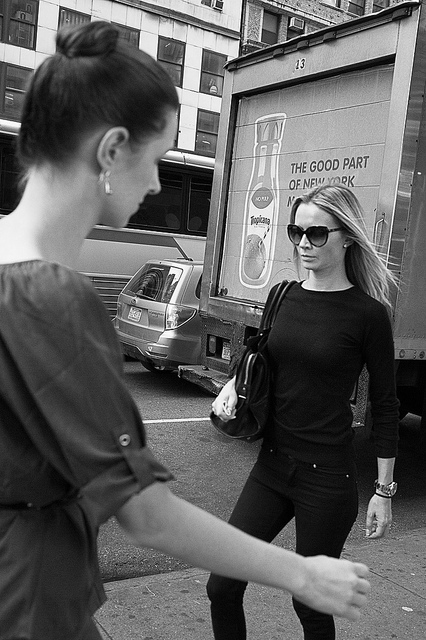Read all the text in this image. THE GOOD PART OF NEW YORK Tropicana 